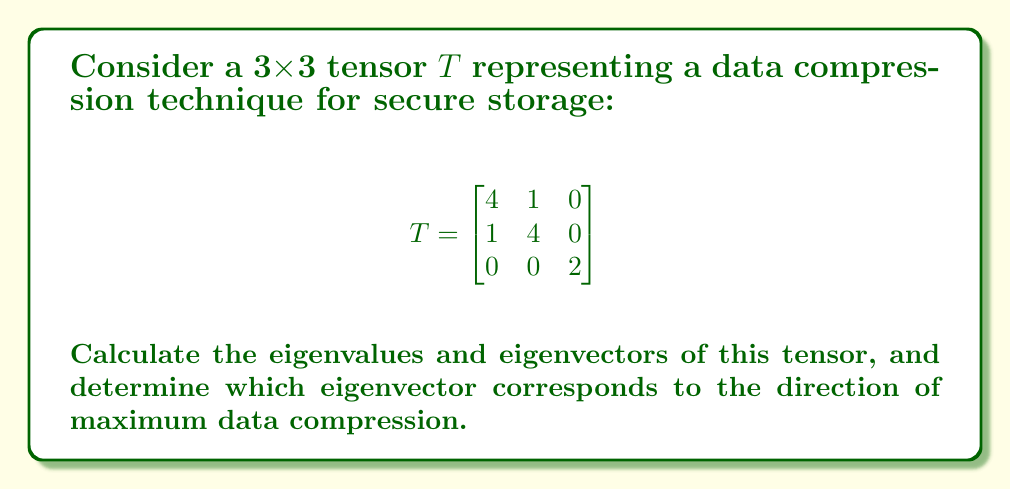Help me with this question. To find the eigenvalues and eigenvectors of the tensor $T$, we follow these steps:

1) Find the characteristic equation:
   $det(T - \lambda I) = 0$
   
   $$\begin{vmatrix}
   4-\lambda & 1 & 0 \\
   1 & 4-\lambda & 0 \\
   0 & 0 & 2-\lambda
   \end{vmatrix} = 0$$

2) Expand the determinant:
   $(4-\lambda)(4-\lambda)(2-\lambda) - 1(4-\lambda) = 0$
   $(4-\lambda)[(4-\lambda)(2-\lambda) - 1] = 0$

3) Solve for $\lambda$:
   $(4-\lambda)[8-6\lambda+\lambda^2 - 1] = 0$
   $(4-\lambda)(\lambda^2-6\lambda+7) = 0$
   
   $\lambda = 4$ or $\lambda^2-6\lambda+7 = 0$
   
   Using the quadratic formula for the second part:
   $\lambda = \frac{6 \pm \sqrt{36-28}}{2} = \frac{6 \pm \sqrt{8}}{2} = 3 \pm \sqrt{2}$

   So, the eigenvalues are: $\lambda_1 = 4$, $\lambda_2 = 3 + \sqrt{2}$, $\lambda_3 = 3 - \sqrt{2}$

4) Find the eigenvectors for each eigenvalue:

   For $\lambda_1 = 4$:
   $$(T - 4I)\vec{v} = \vec{0}$$
   $$\begin{bmatrix}
   0 & 1 & 0 \\
   1 & 0 & 0 \\
   0 & 0 & -2
   \end{bmatrix}\begin{bmatrix}
   v_1 \\ v_2 \\ v_3
   \end{bmatrix} = \begin{bmatrix}
   0 \\ 0 \\ 0
   \end{bmatrix}$$
   
   This gives: $v_1 = -v_2$, $v_3 = 0$
   Eigenvector: $\vec{v_1} = \begin{bmatrix} 1 \\ -1 \\ 0 \end{bmatrix}$

   For $\lambda_2 = 3 + \sqrt{2}$ and $\lambda_3 = 3 - \sqrt{2}$:
   $$(T - \lambda I)\vec{v} = \vec{0}$$
   $$\begin{bmatrix}
   1-\sqrt{2} & 1 & 0 \\
   1 & 1-\sqrt{2} & 0 \\
   0 & 0 & -1\mp\sqrt{2}
   \end{bmatrix}\begin{bmatrix}
   v_1 \\ v_2 \\ v_3
   \end{bmatrix} = \begin{bmatrix}
   0 \\ 0 \\ 0
   \end{bmatrix}$$
   
   This gives: $v_1 = v_2$, $v_3 = 0$
   Eigenvectors: $\vec{v_2} = \begin{bmatrix} 1 \\ 1 \\ 0 \end{bmatrix}$ and $\vec{v_3} = \begin{bmatrix} 0 \\ 0 \\ 1 \end{bmatrix}$

5) The direction of maximum compression corresponds to the eigenvector with the smallest eigenvalue. In this case, it's $\vec{v_3}$ corresponding to $\lambda_3 = 3 - \sqrt{2}$.
Answer: Eigenvalues: $\lambda_1 = 4$, $\lambda_2 = 3 + \sqrt{2}$, $\lambda_3 = 3 - \sqrt{2}$
Eigenvectors: $\vec{v_1} = \begin{bmatrix} 1 \\ -1 \\ 0 \end{bmatrix}$, $\vec{v_2} = \begin{bmatrix} 1 \\ 1 \\ 0 \end{bmatrix}$, $\vec{v_3} = \begin{bmatrix} 0 \\ 0 \\ 1 \end{bmatrix}$
Maximum compression direction: $\vec{v_3} = \begin{bmatrix} 0 \\ 0 \\ 1 \end{bmatrix}$ 